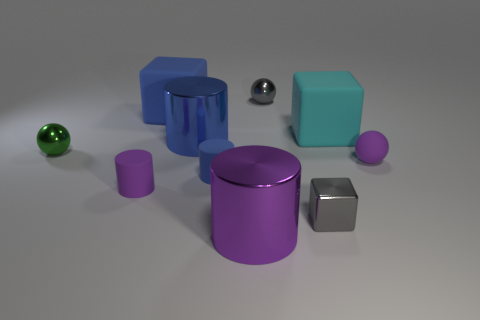Can you describe the lighting and shadows in the scene? The lighting in the image appears to come from above, casting soft shadows on the surface beneath each object. The shadows are fairly diffused, suggesting that the light source is not very close to the objects. What do the shadows tell us about the shape of the objects? The shadows help define the shapes of the objects. For example, the circular shadow suggests a cylindrical or spherical object, while the square and rectangular shadows indicate cube-like shapes. 